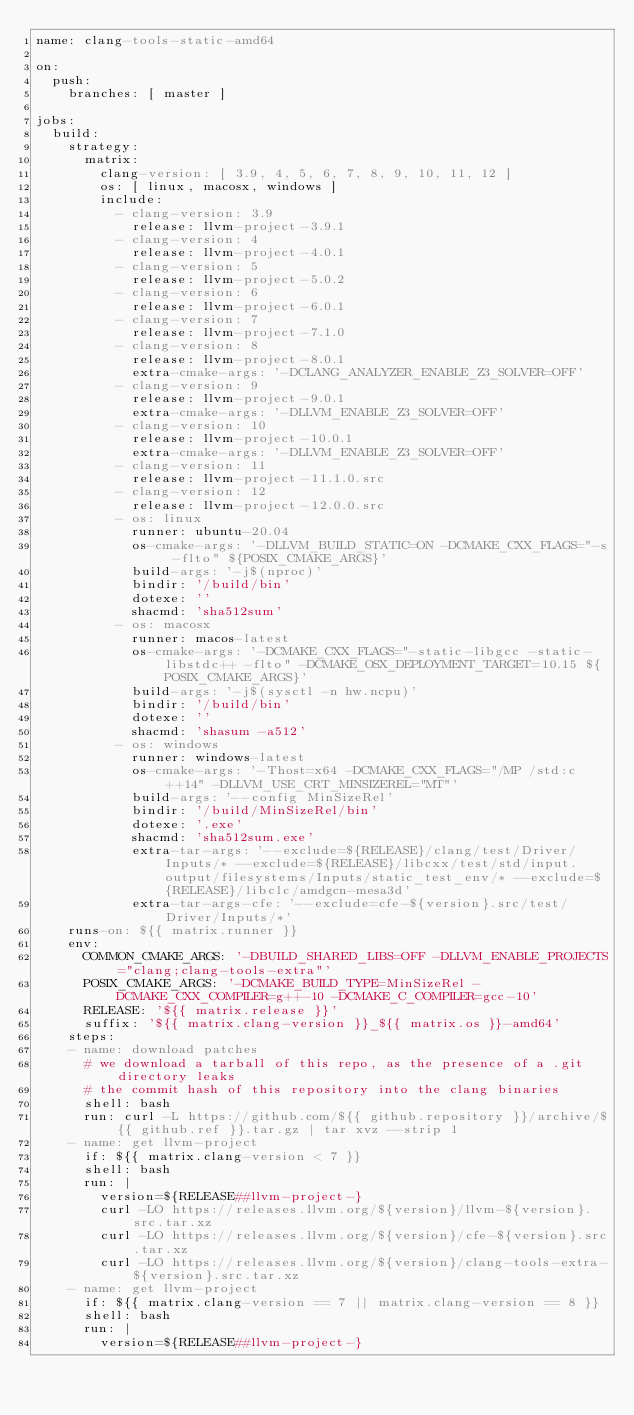Convert code to text. <code><loc_0><loc_0><loc_500><loc_500><_YAML_>name: clang-tools-static-amd64

on:
  push:
    branches: [ master ]

jobs:
  build:
    strategy:
      matrix:
        clang-version: [ 3.9, 4, 5, 6, 7, 8, 9, 10, 11, 12 ]
        os: [ linux, macosx, windows ]
        include:
          - clang-version: 3.9
            release: llvm-project-3.9.1
          - clang-version: 4
            release: llvm-project-4.0.1
          - clang-version: 5
            release: llvm-project-5.0.2
          - clang-version: 6
            release: llvm-project-6.0.1
          - clang-version: 7
            release: llvm-project-7.1.0
          - clang-version: 8
            release: llvm-project-8.0.1
            extra-cmake-args: '-DCLANG_ANALYZER_ENABLE_Z3_SOLVER=OFF'
          - clang-version: 9
            release: llvm-project-9.0.1
            extra-cmake-args: '-DLLVM_ENABLE_Z3_SOLVER=OFF'
          - clang-version: 10
            release: llvm-project-10.0.1
            extra-cmake-args: '-DLLVM_ENABLE_Z3_SOLVER=OFF'
          - clang-version: 11
            release: llvm-project-11.1.0.src
          - clang-version: 12
            release: llvm-project-12.0.0.src
          - os: linux
            runner: ubuntu-20.04
            os-cmake-args: '-DLLVM_BUILD_STATIC=ON -DCMAKE_CXX_FLAGS="-s -flto" ${POSIX_CMAKE_ARGS}'
            build-args: '-j$(nproc)'
            bindir: '/build/bin'
            dotexe: ''
            shacmd: 'sha512sum'
          - os: macosx
            runner: macos-latest
            os-cmake-args: '-DCMAKE_CXX_FLAGS="-static-libgcc -static-libstdc++ -flto" -DCMAKE_OSX_DEPLOYMENT_TARGET=10.15 ${POSIX_CMAKE_ARGS}'
            build-args: '-j$(sysctl -n hw.ncpu)'
            bindir: '/build/bin'
            dotexe: ''
            shacmd: 'shasum -a512'
          - os: windows
            runner: windows-latest
            os-cmake-args: '-Thost=x64 -DCMAKE_CXX_FLAGS="/MP /std:c++14" -DLLVM_USE_CRT_MINSIZEREL="MT"'
            build-args: '--config MinSizeRel'
            bindir: '/build/MinSizeRel/bin'
            dotexe: '.exe'
            shacmd: 'sha512sum.exe'
            extra-tar-args: '--exclude=${RELEASE}/clang/test/Driver/Inputs/* --exclude=${RELEASE}/libcxx/test/std/input.output/filesystems/Inputs/static_test_env/* --exclude=${RELEASE}/libclc/amdgcn-mesa3d'
            extra-tar-args-cfe: '--exclude=cfe-${version}.src/test/Driver/Inputs/*'
    runs-on: ${{ matrix.runner }}
    env:
      COMMON_CMAKE_ARGS: '-DBUILD_SHARED_LIBS=OFF -DLLVM_ENABLE_PROJECTS="clang;clang-tools-extra"'
      POSIX_CMAKE_ARGS: '-DCMAKE_BUILD_TYPE=MinSizeRel -DCMAKE_CXX_COMPILER=g++-10 -DCMAKE_C_COMPILER=gcc-10'
      RELEASE: '${{ matrix.release }}'
      suffix: '${{ matrix.clang-version }}_${{ matrix.os }}-amd64'
    steps:
    - name: download patches
      # we download a tarball of this repo, as the presence of a .git directory leaks
      # the commit hash of this repository into the clang binaries
      shell: bash
      run: curl -L https://github.com/${{ github.repository }}/archive/${{ github.ref }}.tar.gz | tar xvz --strip 1
    - name: get llvm-project
      if: ${{ matrix.clang-version < 7 }}
      shell: bash
      run: |
        version=${RELEASE##llvm-project-}
        curl -LO https://releases.llvm.org/${version}/llvm-${version}.src.tar.xz
        curl -LO https://releases.llvm.org/${version}/cfe-${version}.src.tar.xz
        curl -LO https://releases.llvm.org/${version}/clang-tools-extra-${version}.src.tar.xz
    - name: get llvm-project
      if: ${{ matrix.clang-version == 7 || matrix.clang-version == 8 }}
      shell: bash
      run: |
        version=${RELEASE##llvm-project-}</code> 